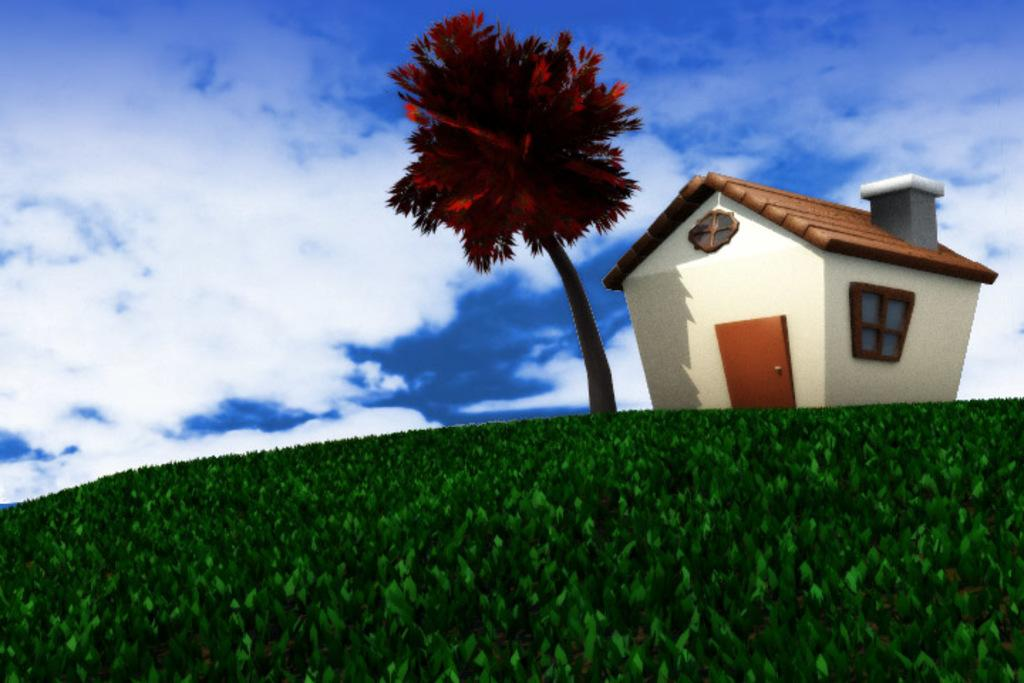What type of image is being described? The image appears to be animated. What can be seen on the ground in the image? There is green grass in the image. What type of plant is present in the image? There is a tree in the image. What type of structure is present in the image? There is a house with windows and a door in the image. What is visible in the sky in the image? There are clouds in the sky in the image. What type of glove is being worn by the tree in the image? There are no gloves present in the image, and the tree is not wearing any clothing or accessories. 